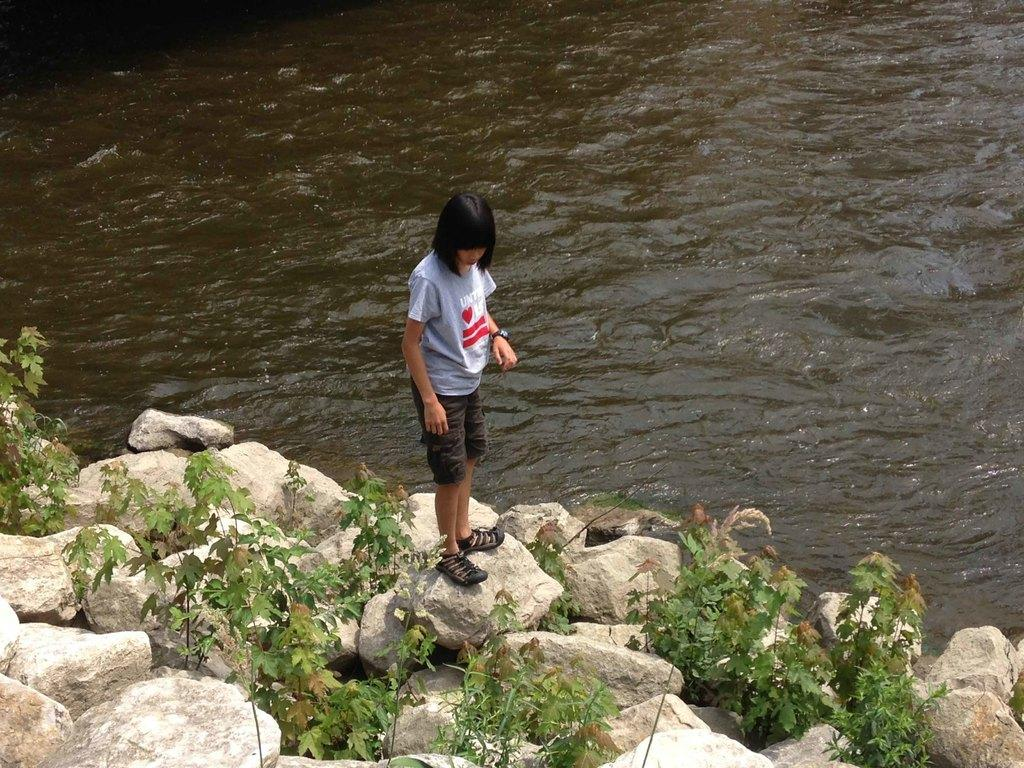Who is present in the image? There is a woman in the picture. Where is the woman located in the image? The woman is standing beside a river. What is the woman standing on? The woman is standing on stones. What can be seen between the stones? There are plants between the stones. What is the woman wearing on her upper body? The woman is wearing a purple top. What is the woman wearing on her lower body? The woman is wearing brown shorts. What type of hair conditioner is the woman using in the image? There is no indication in the image that the woman is using any hair conditioner. 